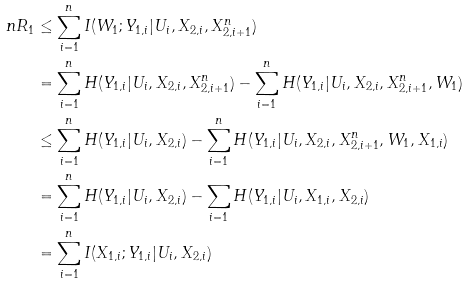Convert formula to latex. <formula><loc_0><loc_0><loc_500><loc_500>n R _ { 1 } & \leq \sum _ { i = 1 } ^ { n } I ( W _ { 1 } ; Y _ { 1 , i } | U _ { i } , X _ { 2 , i } , X _ { 2 , i + 1 } ^ { n } ) \\ & = \sum _ { i = 1 } ^ { n } H ( Y _ { 1 , i } | U _ { i } , X _ { 2 , i } , X _ { 2 , i + 1 } ^ { n } ) - \sum _ { i = 1 } ^ { n } H ( Y _ { 1 , i } | U _ { i } , X _ { 2 , i } , X _ { 2 , i + 1 } ^ { n } , W _ { 1 } ) \\ & \leq \sum _ { i = 1 } ^ { n } H ( Y _ { 1 , i } | U _ { i } , X _ { 2 , i } ) - \sum _ { i = 1 } ^ { n } H ( Y _ { 1 , i } | U _ { i } , X _ { 2 , i } , X _ { 2 , i + 1 } ^ { n } , W _ { 1 } , X _ { 1 , i } ) \\ & = \sum _ { i = 1 } ^ { n } H ( Y _ { 1 , i } | U _ { i } , X _ { 2 , i } ) - \sum _ { i = 1 } H ( Y _ { 1 , i } | U _ { i } , X _ { 1 , i } , X _ { 2 , i } ) \\ & = \sum _ { i = 1 } ^ { n } I ( X _ { 1 , i } ; Y _ { 1 , i } | U _ { i } , X _ { 2 , i } )</formula> 